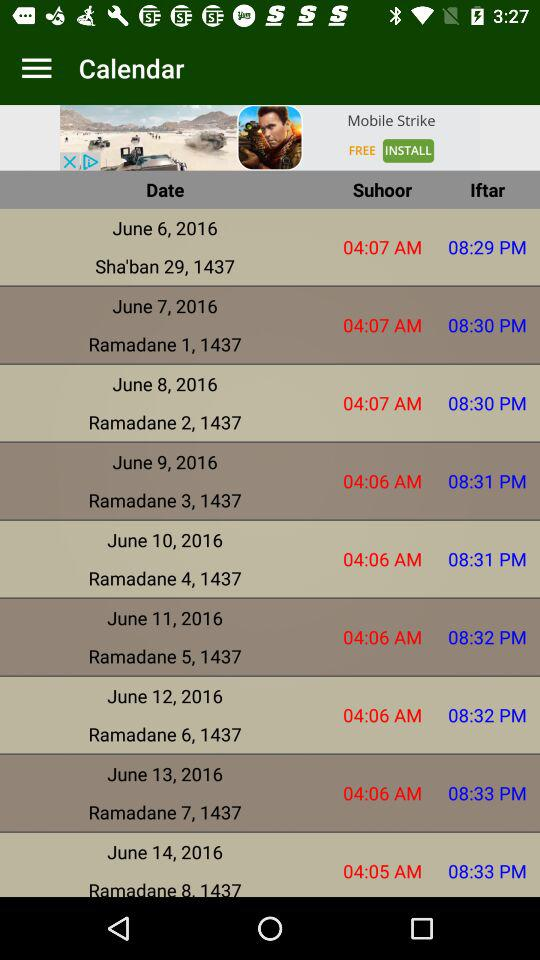What is the date of Sha'ban 29, 1437? The date is June 6, 2017. 